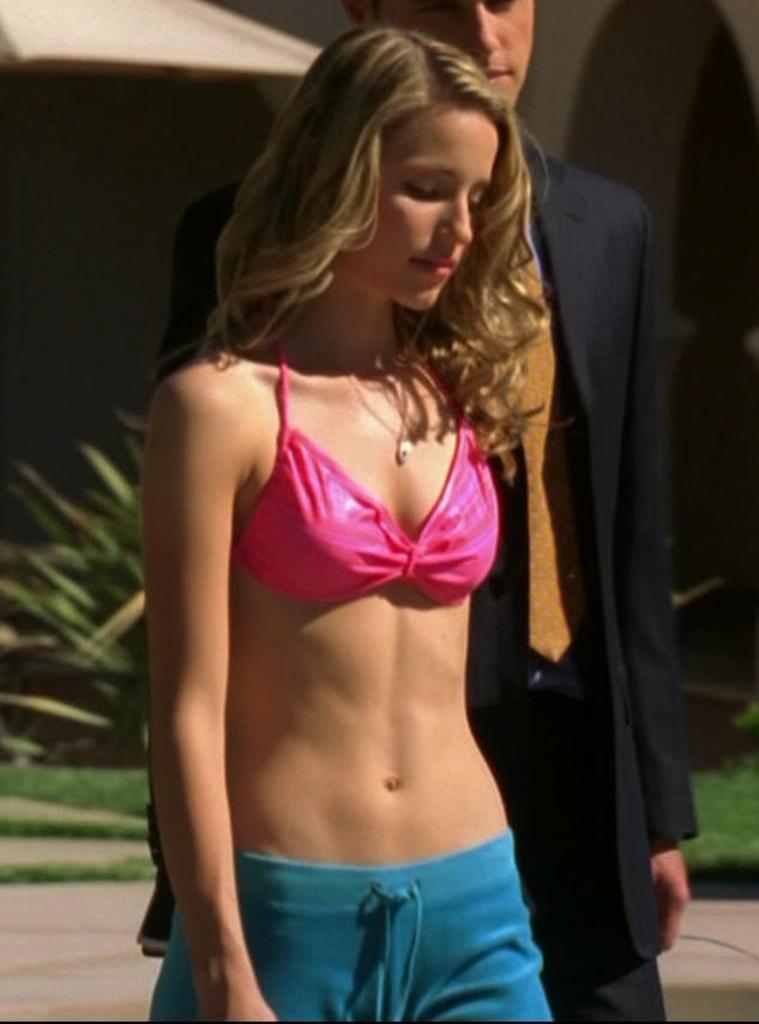Describe this image in one or two sentences. This picture shows a girl and a man standing and we see an umbrella and plants. we see grass on the ground and men wore coat and tie 